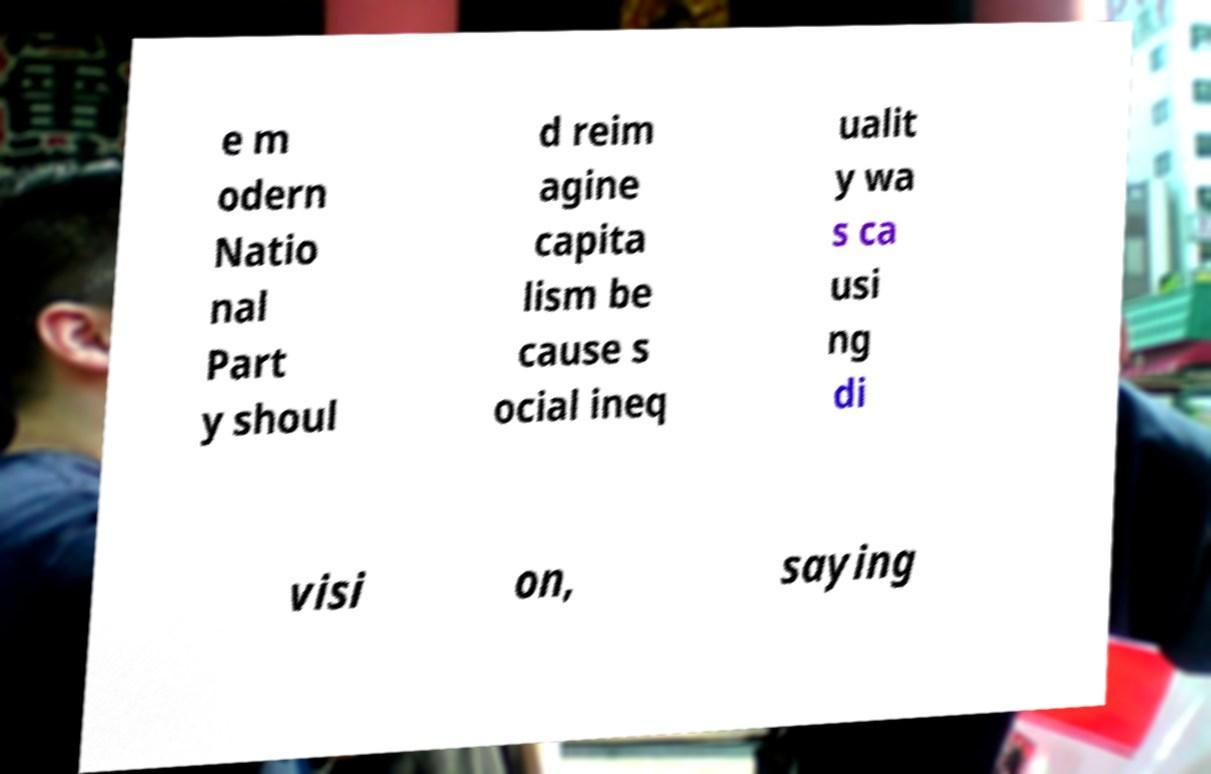There's text embedded in this image that I need extracted. Can you transcribe it verbatim? e m odern Natio nal Part y shoul d reim agine capita lism be cause s ocial ineq ualit y wa s ca usi ng di visi on, saying 